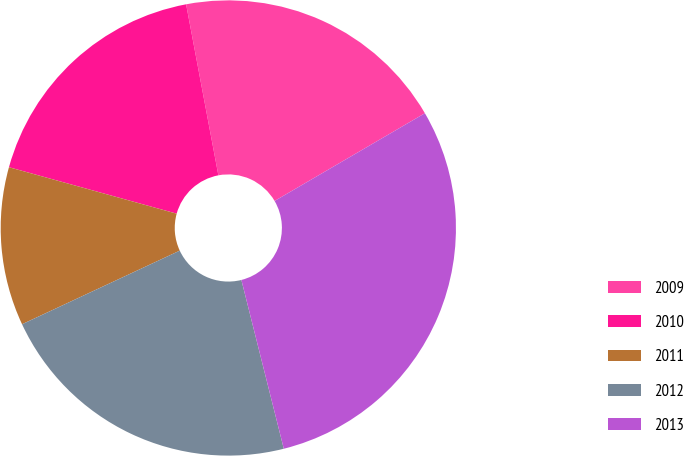Convert chart to OTSL. <chart><loc_0><loc_0><loc_500><loc_500><pie_chart><fcel>2009<fcel>2010<fcel>2011<fcel>2012<fcel>2013<nl><fcel>19.56%<fcel>17.73%<fcel>11.25%<fcel>21.97%<fcel>29.49%<nl></chart> 